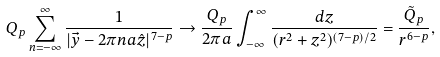Convert formula to latex. <formula><loc_0><loc_0><loc_500><loc_500>Q _ { p } \sum _ { n = - \infty } ^ { \infty } \frac { 1 } { | \vec { y } - 2 \pi n a \hat { z } | ^ { 7 - p } } \rightarrow \frac { Q _ { p } } { 2 \pi a } \int _ { - \infty } ^ { \infty } \frac { d z } { ( r ^ { 2 } + z ^ { 2 } ) ^ { ( 7 - p ) / 2 } } = \frac { \tilde { Q } _ { p } } { r ^ { 6 - p } } ,</formula> 